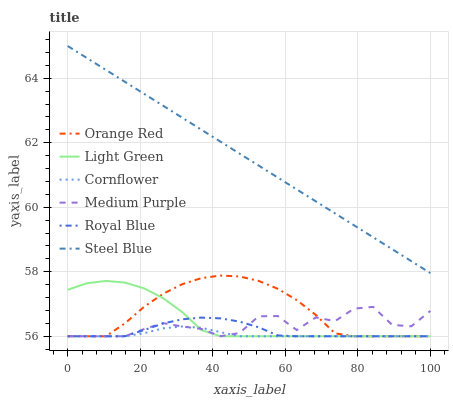Does Cornflower have the minimum area under the curve?
Answer yes or no. Yes. Does Steel Blue have the maximum area under the curve?
Answer yes or no. Yes. Does Medium Purple have the minimum area under the curve?
Answer yes or no. No. Does Medium Purple have the maximum area under the curve?
Answer yes or no. No. Is Steel Blue the smoothest?
Answer yes or no. Yes. Is Medium Purple the roughest?
Answer yes or no. Yes. Is Medium Purple the smoothest?
Answer yes or no. No. Is Steel Blue the roughest?
Answer yes or no. No. Does Cornflower have the lowest value?
Answer yes or no. Yes. Does Steel Blue have the lowest value?
Answer yes or no. No. Does Steel Blue have the highest value?
Answer yes or no. Yes. Does Medium Purple have the highest value?
Answer yes or no. No. Is Cornflower less than Steel Blue?
Answer yes or no. Yes. Is Steel Blue greater than Orange Red?
Answer yes or no. Yes. Does Royal Blue intersect Cornflower?
Answer yes or no. Yes. Is Royal Blue less than Cornflower?
Answer yes or no. No. Is Royal Blue greater than Cornflower?
Answer yes or no. No. Does Cornflower intersect Steel Blue?
Answer yes or no. No. 